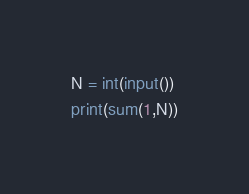Convert code to text. <code><loc_0><loc_0><loc_500><loc_500><_Python_>N = int(input())
print(sum(1,N))</code> 